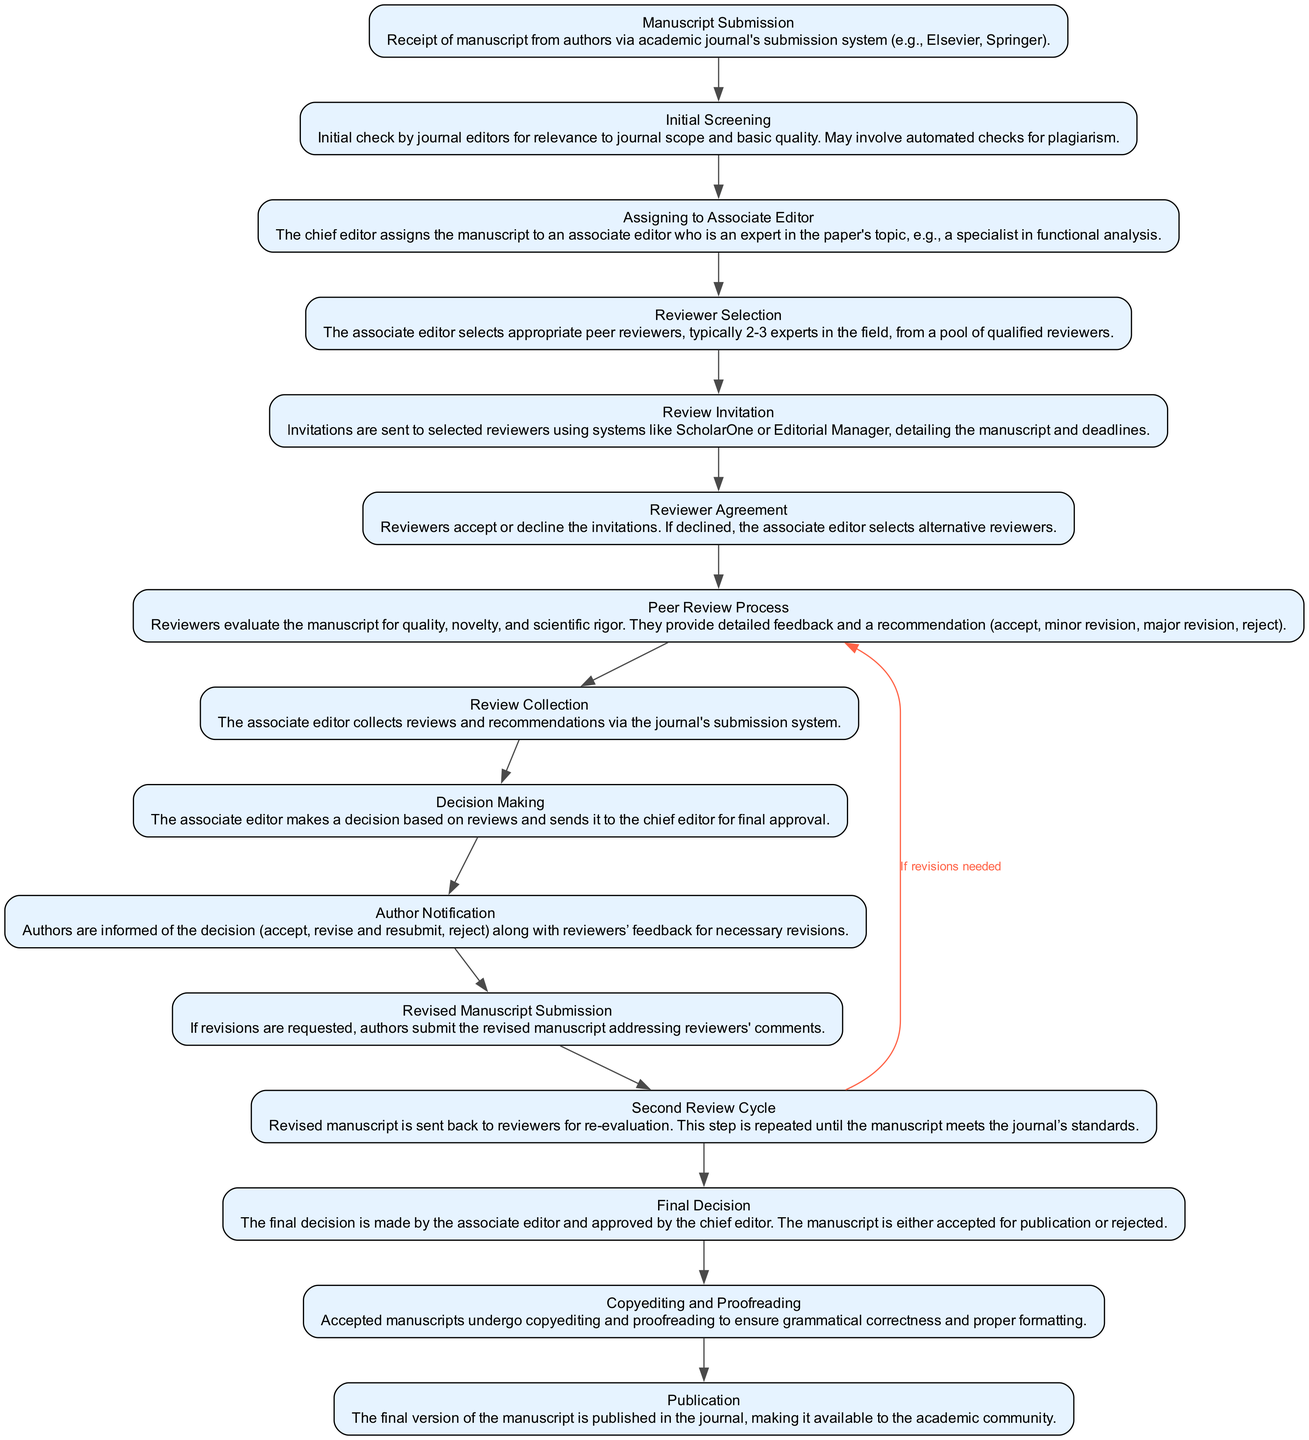What is the first step in the peer review workflow? The peer review workflow begins with "Manuscript Submission," where the manuscript is received from authors via the journal's submission system.
Answer: Manuscript Submission How many main review stages are indicated in the diagram? The diagram has several stages, but notable main stages including "Peer Review Process," "Review Collection," and "Final Decision" can be counted. Upon reviewing, there are 14 distinct stages.
Answer: 14 What action follows the "Reviewer Agreement"? After "Reviewer Agreement," the process moves to the "Peer Review Process," where reviewers evaluate the manuscript and provide feedback.
Answer: Peer Review Process What is the relationship between "Revised Manuscript Submission" and "Second Review Cycle"? "Revised Manuscript Submission" is directly linked to "Second Review Cycle" as the revised manuscript is sent back for re-evaluation, indicating a sequential flow.
Answer: Sequential What happens if reviewers decline to review? If reviewers decline the invitation, the associate editor selects alternative reviewers, ensuring the review process continues without interruption.
Answer: Selects alternative reviewers What document does the "Author Notification" step provide to authors? The "Author Notification" step informs authors of the decision regarding their manuscript and includes the feedback from reviewers for necessary revisions.
Answer: Decision and feedback Which step comes after "Decision Making"? Following "Decision Making," the next step is "Author Notification," where the outcomes of the decision-making are communicated to the authors.
Answer: Author Notification In which step are manuscripts subjected to language and formatting corrections? The step where manuscripts undergo language and formatting corrections is called "Copyediting and Proofreading," ensuring high standards before publication.
Answer: Copyediting and Proofreading What is the outcome of the "Final Decision" step? The outcome of the "Final Decision" step results in the manuscript being either accepted for publication or rejected, ensuring a conclusive resolution to the peer review process.
Answer: Accepted or rejected 